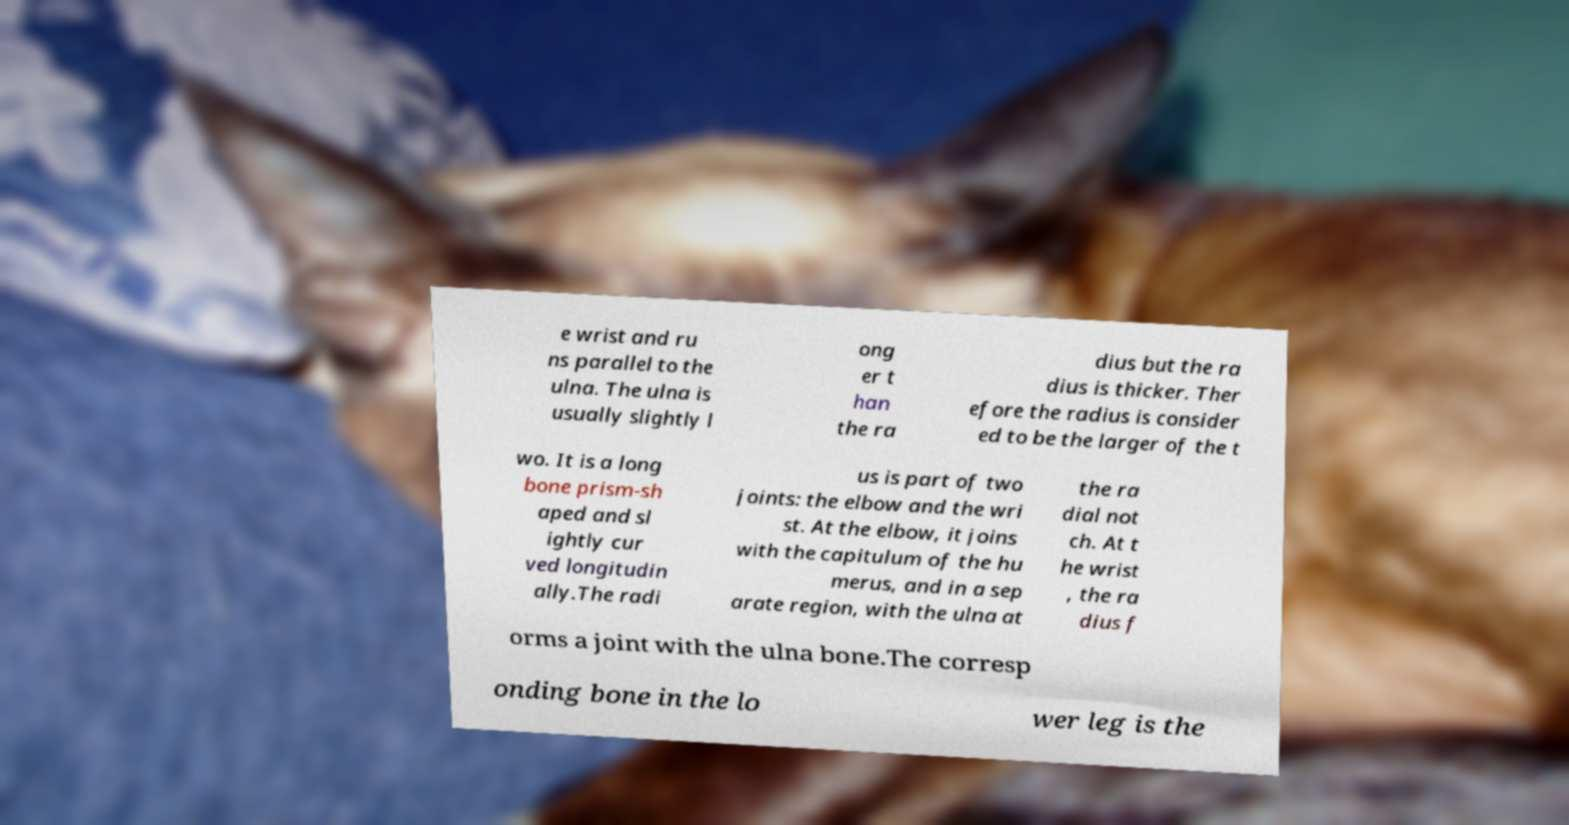Could you extract and type out the text from this image? e wrist and ru ns parallel to the ulna. The ulna is usually slightly l ong er t han the ra dius but the ra dius is thicker. Ther efore the radius is consider ed to be the larger of the t wo. It is a long bone prism-sh aped and sl ightly cur ved longitudin ally.The radi us is part of two joints: the elbow and the wri st. At the elbow, it joins with the capitulum of the hu merus, and in a sep arate region, with the ulna at the ra dial not ch. At t he wrist , the ra dius f orms a joint with the ulna bone.The corresp onding bone in the lo wer leg is the 